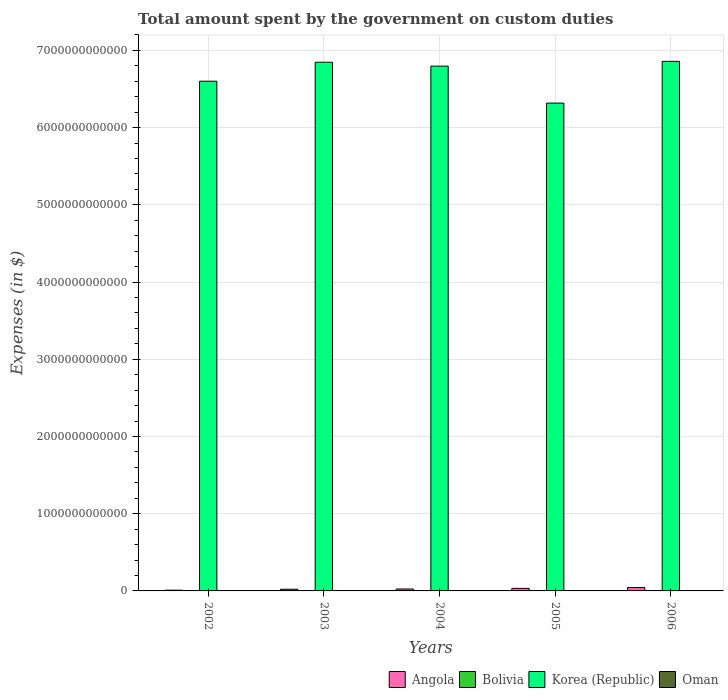Are the number of bars per tick equal to the number of legend labels?
Offer a very short reply. Yes. In how many cases, is the number of bars for a given year not equal to the number of legend labels?
Ensure brevity in your answer.  0. What is the amount spent on custom duties by the government in Korea (Republic) in 2002?
Give a very brief answer. 6.60e+12. Across all years, what is the maximum amount spent on custom duties by the government in Bolivia?
Give a very brief answer. 7.50e+08. Across all years, what is the minimum amount spent on custom duties by the government in Angola?
Ensure brevity in your answer.  9.70e+09. In which year was the amount spent on custom duties by the government in Korea (Republic) maximum?
Offer a terse response. 2006. What is the total amount spent on custom duties by the government in Korea (Republic) in the graph?
Ensure brevity in your answer.  3.34e+13. What is the difference between the amount spent on custom duties by the government in Angola in 2003 and that in 2004?
Make the answer very short. -2.82e+09. What is the difference between the amount spent on custom duties by the government in Korea (Republic) in 2005 and the amount spent on custom duties by the government in Oman in 2002?
Offer a very short reply. 6.32e+12. What is the average amount spent on custom duties by the government in Bolivia per year?
Offer a very short reply. 5.74e+08. In the year 2002, what is the difference between the amount spent on custom duties by the government in Oman and amount spent on custom duties by the government in Korea (Republic)?
Offer a very short reply. -6.60e+12. In how many years, is the amount spent on custom duties by the government in Korea (Republic) greater than 5600000000000 $?
Ensure brevity in your answer.  5. What is the ratio of the amount spent on custom duties by the government in Bolivia in 2003 to that in 2006?
Offer a terse response. 0.61. Is the amount spent on custom duties by the government in Angola in 2003 less than that in 2006?
Make the answer very short. Yes. What is the difference between the highest and the second highest amount spent on custom duties by the government in Bolivia?
Your response must be concise. 1.02e+08. What is the difference between the highest and the lowest amount spent on custom duties by the government in Korea (Republic)?
Ensure brevity in your answer.  5.41e+11. Is the sum of the amount spent on custom duties by the government in Korea (Republic) in 2002 and 2006 greater than the maximum amount spent on custom duties by the government in Oman across all years?
Keep it short and to the point. Yes. Is it the case that in every year, the sum of the amount spent on custom duties by the government in Bolivia and amount spent on custom duties by the government in Angola is greater than the sum of amount spent on custom duties by the government in Korea (Republic) and amount spent on custom duties by the government in Oman?
Keep it short and to the point. No. What does the 4th bar from the right in 2006 represents?
Provide a short and direct response. Angola. Is it the case that in every year, the sum of the amount spent on custom duties by the government in Korea (Republic) and amount spent on custom duties by the government in Angola is greater than the amount spent on custom duties by the government in Bolivia?
Give a very brief answer. Yes. How many bars are there?
Provide a short and direct response. 20. How many years are there in the graph?
Your answer should be very brief. 5. What is the difference between two consecutive major ticks on the Y-axis?
Your response must be concise. 1.00e+12. Are the values on the major ticks of Y-axis written in scientific E-notation?
Ensure brevity in your answer.  No. Does the graph contain grids?
Your response must be concise. Yes. How are the legend labels stacked?
Your answer should be compact. Horizontal. What is the title of the graph?
Your answer should be compact. Total amount spent by the government on custom duties. Does "Ukraine" appear as one of the legend labels in the graph?
Offer a terse response. No. What is the label or title of the X-axis?
Provide a short and direct response. Years. What is the label or title of the Y-axis?
Your response must be concise. Expenses (in $). What is the Expenses (in $) of Angola in 2002?
Provide a succinct answer. 9.70e+09. What is the Expenses (in $) of Bolivia in 2002?
Make the answer very short. 4.88e+08. What is the Expenses (in $) of Korea (Republic) in 2002?
Provide a succinct answer. 6.60e+12. What is the Expenses (in $) of Oman in 2002?
Offer a terse response. 6.02e+07. What is the Expenses (in $) in Angola in 2003?
Keep it short and to the point. 2.20e+1. What is the Expenses (in $) in Bolivia in 2003?
Provide a succinct answer. 4.55e+08. What is the Expenses (in $) of Korea (Republic) in 2003?
Make the answer very short. 6.85e+12. What is the Expenses (in $) of Oman in 2003?
Your response must be concise. 6.50e+07. What is the Expenses (in $) of Angola in 2004?
Give a very brief answer. 2.48e+1. What is the Expenses (in $) of Bolivia in 2004?
Your response must be concise. 5.28e+08. What is the Expenses (in $) in Korea (Republic) in 2004?
Your answer should be compact. 6.80e+12. What is the Expenses (in $) of Oman in 2004?
Provide a succinct answer. 7.10e+07. What is the Expenses (in $) in Angola in 2005?
Your answer should be very brief. 3.32e+1. What is the Expenses (in $) of Bolivia in 2005?
Offer a very short reply. 6.48e+08. What is the Expenses (in $) of Korea (Republic) in 2005?
Offer a terse response. 6.32e+12. What is the Expenses (in $) in Oman in 2005?
Give a very brief answer. 8.85e+07. What is the Expenses (in $) in Angola in 2006?
Provide a succinct answer. 4.37e+1. What is the Expenses (in $) of Bolivia in 2006?
Keep it short and to the point. 7.50e+08. What is the Expenses (in $) of Korea (Republic) in 2006?
Ensure brevity in your answer.  6.86e+12. What is the Expenses (in $) of Oman in 2006?
Keep it short and to the point. 1.15e+08. Across all years, what is the maximum Expenses (in $) in Angola?
Your answer should be very brief. 4.37e+1. Across all years, what is the maximum Expenses (in $) of Bolivia?
Your response must be concise. 7.50e+08. Across all years, what is the maximum Expenses (in $) in Korea (Republic)?
Your answer should be compact. 6.86e+12. Across all years, what is the maximum Expenses (in $) in Oman?
Keep it short and to the point. 1.15e+08. Across all years, what is the minimum Expenses (in $) in Angola?
Provide a short and direct response. 9.70e+09. Across all years, what is the minimum Expenses (in $) of Bolivia?
Make the answer very short. 4.55e+08. Across all years, what is the minimum Expenses (in $) of Korea (Republic)?
Provide a succinct answer. 6.32e+12. Across all years, what is the minimum Expenses (in $) of Oman?
Ensure brevity in your answer.  6.02e+07. What is the total Expenses (in $) in Angola in the graph?
Provide a succinct answer. 1.33e+11. What is the total Expenses (in $) of Bolivia in the graph?
Provide a succinct answer. 2.87e+09. What is the total Expenses (in $) of Korea (Republic) in the graph?
Provide a short and direct response. 3.34e+13. What is the total Expenses (in $) in Oman in the graph?
Give a very brief answer. 3.99e+08. What is the difference between the Expenses (in $) of Angola in 2002 and that in 2003?
Provide a short and direct response. -1.23e+1. What is the difference between the Expenses (in $) in Bolivia in 2002 and that in 2003?
Your answer should be very brief. 3.30e+07. What is the difference between the Expenses (in $) in Korea (Republic) in 2002 and that in 2003?
Your response must be concise. -2.46e+11. What is the difference between the Expenses (in $) of Oman in 2002 and that in 2003?
Offer a terse response. -4.80e+06. What is the difference between the Expenses (in $) in Angola in 2002 and that in 2004?
Give a very brief answer. -1.51e+1. What is the difference between the Expenses (in $) of Bolivia in 2002 and that in 2004?
Make the answer very short. -4.01e+07. What is the difference between the Expenses (in $) of Korea (Republic) in 2002 and that in 2004?
Give a very brief answer. -1.95e+11. What is the difference between the Expenses (in $) in Oman in 2002 and that in 2004?
Offer a terse response. -1.08e+07. What is the difference between the Expenses (in $) of Angola in 2002 and that in 2005?
Offer a terse response. -2.35e+1. What is the difference between the Expenses (in $) in Bolivia in 2002 and that in 2005?
Your answer should be compact. -1.60e+08. What is the difference between the Expenses (in $) in Korea (Republic) in 2002 and that in 2005?
Offer a very short reply. 2.84e+11. What is the difference between the Expenses (in $) of Oman in 2002 and that in 2005?
Ensure brevity in your answer.  -2.83e+07. What is the difference between the Expenses (in $) in Angola in 2002 and that in 2006?
Your response must be concise. -3.40e+1. What is the difference between the Expenses (in $) of Bolivia in 2002 and that in 2006?
Your answer should be compact. -2.62e+08. What is the difference between the Expenses (in $) of Korea (Republic) in 2002 and that in 2006?
Provide a succinct answer. -2.57e+11. What is the difference between the Expenses (in $) in Oman in 2002 and that in 2006?
Keep it short and to the point. -5.44e+07. What is the difference between the Expenses (in $) in Angola in 2003 and that in 2004?
Give a very brief answer. -2.82e+09. What is the difference between the Expenses (in $) of Bolivia in 2003 and that in 2004?
Your response must be concise. -7.31e+07. What is the difference between the Expenses (in $) in Korea (Republic) in 2003 and that in 2004?
Offer a terse response. 5.08e+1. What is the difference between the Expenses (in $) in Oman in 2003 and that in 2004?
Your answer should be compact. -6.00e+06. What is the difference between the Expenses (in $) of Angola in 2003 and that in 2005?
Your response must be concise. -1.12e+1. What is the difference between the Expenses (in $) of Bolivia in 2003 and that in 2005?
Your answer should be very brief. -1.93e+08. What is the difference between the Expenses (in $) of Korea (Republic) in 2003 and that in 2005?
Offer a terse response. 5.30e+11. What is the difference between the Expenses (in $) in Oman in 2003 and that in 2005?
Provide a short and direct response. -2.35e+07. What is the difference between the Expenses (in $) of Angola in 2003 and that in 2006?
Provide a short and direct response. -2.17e+1. What is the difference between the Expenses (in $) of Bolivia in 2003 and that in 2006?
Your answer should be very brief. -2.95e+08. What is the difference between the Expenses (in $) of Korea (Republic) in 2003 and that in 2006?
Provide a short and direct response. -1.11e+1. What is the difference between the Expenses (in $) of Oman in 2003 and that in 2006?
Offer a very short reply. -4.96e+07. What is the difference between the Expenses (in $) of Angola in 2004 and that in 2005?
Offer a very short reply. -8.36e+09. What is the difference between the Expenses (in $) of Bolivia in 2004 and that in 2005?
Your answer should be compact. -1.20e+08. What is the difference between the Expenses (in $) in Korea (Republic) in 2004 and that in 2005?
Provide a short and direct response. 4.79e+11. What is the difference between the Expenses (in $) in Oman in 2004 and that in 2005?
Offer a terse response. -1.75e+07. What is the difference between the Expenses (in $) of Angola in 2004 and that in 2006?
Offer a very short reply. -1.89e+1. What is the difference between the Expenses (in $) of Bolivia in 2004 and that in 2006?
Provide a short and direct response. -2.22e+08. What is the difference between the Expenses (in $) in Korea (Republic) in 2004 and that in 2006?
Give a very brief answer. -6.19e+1. What is the difference between the Expenses (in $) of Oman in 2004 and that in 2006?
Ensure brevity in your answer.  -4.36e+07. What is the difference between the Expenses (in $) of Angola in 2005 and that in 2006?
Offer a very short reply. -1.05e+1. What is the difference between the Expenses (in $) in Bolivia in 2005 and that in 2006?
Give a very brief answer. -1.02e+08. What is the difference between the Expenses (in $) in Korea (Republic) in 2005 and that in 2006?
Keep it short and to the point. -5.41e+11. What is the difference between the Expenses (in $) in Oman in 2005 and that in 2006?
Your response must be concise. -2.61e+07. What is the difference between the Expenses (in $) in Angola in 2002 and the Expenses (in $) in Bolivia in 2003?
Keep it short and to the point. 9.25e+09. What is the difference between the Expenses (in $) of Angola in 2002 and the Expenses (in $) of Korea (Republic) in 2003?
Ensure brevity in your answer.  -6.84e+12. What is the difference between the Expenses (in $) in Angola in 2002 and the Expenses (in $) in Oman in 2003?
Offer a very short reply. 9.64e+09. What is the difference between the Expenses (in $) in Bolivia in 2002 and the Expenses (in $) in Korea (Republic) in 2003?
Offer a very short reply. -6.85e+12. What is the difference between the Expenses (in $) of Bolivia in 2002 and the Expenses (in $) of Oman in 2003?
Give a very brief answer. 4.23e+08. What is the difference between the Expenses (in $) of Korea (Republic) in 2002 and the Expenses (in $) of Oman in 2003?
Ensure brevity in your answer.  6.60e+12. What is the difference between the Expenses (in $) in Angola in 2002 and the Expenses (in $) in Bolivia in 2004?
Your response must be concise. 9.17e+09. What is the difference between the Expenses (in $) of Angola in 2002 and the Expenses (in $) of Korea (Republic) in 2004?
Make the answer very short. -6.79e+12. What is the difference between the Expenses (in $) in Angola in 2002 and the Expenses (in $) in Oman in 2004?
Keep it short and to the point. 9.63e+09. What is the difference between the Expenses (in $) in Bolivia in 2002 and the Expenses (in $) in Korea (Republic) in 2004?
Provide a short and direct response. -6.80e+12. What is the difference between the Expenses (in $) in Bolivia in 2002 and the Expenses (in $) in Oman in 2004?
Keep it short and to the point. 4.17e+08. What is the difference between the Expenses (in $) of Korea (Republic) in 2002 and the Expenses (in $) of Oman in 2004?
Ensure brevity in your answer.  6.60e+12. What is the difference between the Expenses (in $) of Angola in 2002 and the Expenses (in $) of Bolivia in 2005?
Your answer should be compact. 9.05e+09. What is the difference between the Expenses (in $) of Angola in 2002 and the Expenses (in $) of Korea (Republic) in 2005?
Make the answer very short. -6.31e+12. What is the difference between the Expenses (in $) of Angola in 2002 and the Expenses (in $) of Oman in 2005?
Make the answer very short. 9.61e+09. What is the difference between the Expenses (in $) in Bolivia in 2002 and the Expenses (in $) in Korea (Republic) in 2005?
Provide a short and direct response. -6.32e+12. What is the difference between the Expenses (in $) in Bolivia in 2002 and the Expenses (in $) in Oman in 2005?
Provide a succinct answer. 4.00e+08. What is the difference between the Expenses (in $) in Korea (Republic) in 2002 and the Expenses (in $) in Oman in 2005?
Provide a succinct answer. 6.60e+12. What is the difference between the Expenses (in $) of Angola in 2002 and the Expenses (in $) of Bolivia in 2006?
Ensure brevity in your answer.  8.95e+09. What is the difference between the Expenses (in $) in Angola in 2002 and the Expenses (in $) in Korea (Republic) in 2006?
Your answer should be very brief. -6.85e+12. What is the difference between the Expenses (in $) in Angola in 2002 and the Expenses (in $) in Oman in 2006?
Your answer should be compact. 9.59e+09. What is the difference between the Expenses (in $) of Bolivia in 2002 and the Expenses (in $) of Korea (Republic) in 2006?
Offer a terse response. -6.86e+12. What is the difference between the Expenses (in $) of Bolivia in 2002 and the Expenses (in $) of Oman in 2006?
Make the answer very short. 3.74e+08. What is the difference between the Expenses (in $) in Korea (Republic) in 2002 and the Expenses (in $) in Oman in 2006?
Keep it short and to the point. 6.60e+12. What is the difference between the Expenses (in $) in Angola in 2003 and the Expenses (in $) in Bolivia in 2004?
Keep it short and to the point. 2.14e+1. What is the difference between the Expenses (in $) in Angola in 2003 and the Expenses (in $) in Korea (Republic) in 2004?
Offer a terse response. -6.77e+12. What is the difference between the Expenses (in $) of Angola in 2003 and the Expenses (in $) of Oman in 2004?
Offer a very short reply. 2.19e+1. What is the difference between the Expenses (in $) in Bolivia in 2003 and the Expenses (in $) in Korea (Republic) in 2004?
Your answer should be very brief. -6.80e+12. What is the difference between the Expenses (in $) in Bolivia in 2003 and the Expenses (in $) in Oman in 2004?
Keep it short and to the point. 3.84e+08. What is the difference between the Expenses (in $) of Korea (Republic) in 2003 and the Expenses (in $) of Oman in 2004?
Offer a very short reply. 6.85e+12. What is the difference between the Expenses (in $) in Angola in 2003 and the Expenses (in $) in Bolivia in 2005?
Offer a terse response. 2.13e+1. What is the difference between the Expenses (in $) of Angola in 2003 and the Expenses (in $) of Korea (Republic) in 2005?
Offer a terse response. -6.30e+12. What is the difference between the Expenses (in $) in Angola in 2003 and the Expenses (in $) in Oman in 2005?
Provide a succinct answer. 2.19e+1. What is the difference between the Expenses (in $) of Bolivia in 2003 and the Expenses (in $) of Korea (Republic) in 2005?
Give a very brief answer. -6.32e+12. What is the difference between the Expenses (in $) of Bolivia in 2003 and the Expenses (in $) of Oman in 2005?
Your response must be concise. 3.67e+08. What is the difference between the Expenses (in $) of Korea (Republic) in 2003 and the Expenses (in $) of Oman in 2005?
Provide a short and direct response. 6.85e+12. What is the difference between the Expenses (in $) in Angola in 2003 and the Expenses (in $) in Bolivia in 2006?
Your answer should be very brief. 2.12e+1. What is the difference between the Expenses (in $) of Angola in 2003 and the Expenses (in $) of Korea (Republic) in 2006?
Provide a succinct answer. -6.84e+12. What is the difference between the Expenses (in $) of Angola in 2003 and the Expenses (in $) of Oman in 2006?
Provide a short and direct response. 2.19e+1. What is the difference between the Expenses (in $) of Bolivia in 2003 and the Expenses (in $) of Korea (Republic) in 2006?
Provide a succinct answer. -6.86e+12. What is the difference between the Expenses (in $) of Bolivia in 2003 and the Expenses (in $) of Oman in 2006?
Provide a short and direct response. 3.41e+08. What is the difference between the Expenses (in $) of Korea (Republic) in 2003 and the Expenses (in $) of Oman in 2006?
Your answer should be compact. 6.85e+12. What is the difference between the Expenses (in $) in Angola in 2004 and the Expenses (in $) in Bolivia in 2005?
Your answer should be compact. 2.41e+1. What is the difference between the Expenses (in $) of Angola in 2004 and the Expenses (in $) of Korea (Republic) in 2005?
Keep it short and to the point. -6.29e+12. What is the difference between the Expenses (in $) in Angola in 2004 and the Expenses (in $) in Oman in 2005?
Ensure brevity in your answer.  2.47e+1. What is the difference between the Expenses (in $) of Bolivia in 2004 and the Expenses (in $) of Korea (Republic) in 2005?
Keep it short and to the point. -6.32e+12. What is the difference between the Expenses (in $) in Bolivia in 2004 and the Expenses (in $) in Oman in 2005?
Your answer should be very brief. 4.40e+08. What is the difference between the Expenses (in $) of Korea (Republic) in 2004 and the Expenses (in $) of Oman in 2005?
Offer a very short reply. 6.80e+12. What is the difference between the Expenses (in $) in Angola in 2004 and the Expenses (in $) in Bolivia in 2006?
Offer a terse response. 2.40e+1. What is the difference between the Expenses (in $) in Angola in 2004 and the Expenses (in $) in Korea (Republic) in 2006?
Your response must be concise. -6.83e+12. What is the difference between the Expenses (in $) in Angola in 2004 and the Expenses (in $) in Oman in 2006?
Your response must be concise. 2.47e+1. What is the difference between the Expenses (in $) of Bolivia in 2004 and the Expenses (in $) of Korea (Republic) in 2006?
Your answer should be very brief. -6.86e+12. What is the difference between the Expenses (in $) in Bolivia in 2004 and the Expenses (in $) in Oman in 2006?
Offer a terse response. 4.14e+08. What is the difference between the Expenses (in $) of Korea (Republic) in 2004 and the Expenses (in $) of Oman in 2006?
Offer a terse response. 6.80e+12. What is the difference between the Expenses (in $) of Angola in 2005 and the Expenses (in $) of Bolivia in 2006?
Your response must be concise. 3.24e+1. What is the difference between the Expenses (in $) of Angola in 2005 and the Expenses (in $) of Korea (Republic) in 2006?
Your response must be concise. -6.83e+12. What is the difference between the Expenses (in $) of Angola in 2005 and the Expenses (in $) of Oman in 2006?
Give a very brief answer. 3.30e+1. What is the difference between the Expenses (in $) of Bolivia in 2005 and the Expenses (in $) of Korea (Republic) in 2006?
Offer a terse response. -6.86e+12. What is the difference between the Expenses (in $) in Bolivia in 2005 and the Expenses (in $) in Oman in 2006?
Your answer should be compact. 5.34e+08. What is the difference between the Expenses (in $) in Korea (Republic) in 2005 and the Expenses (in $) in Oman in 2006?
Your response must be concise. 6.32e+12. What is the average Expenses (in $) of Angola per year?
Ensure brevity in your answer.  2.67e+1. What is the average Expenses (in $) in Bolivia per year?
Your answer should be very brief. 5.74e+08. What is the average Expenses (in $) in Korea (Republic) per year?
Your response must be concise. 6.68e+12. What is the average Expenses (in $) in Oman per year?
Make the answer very short. 7.99e+07. In the year 2002, what is the difference between the Expenses (in $) of Angola and Expenses (in $) of Bolivia?
Provide a short and direct response. 9.21e+09. In the year 2002, what is the difference between the Expenses (in $) of Angola and Expenses (in $) of Korea (Republic)?
Your answer should be compact. -6.59e+12. In the year 2002, what is the difference between the Expenses (in $) of Angola and Expenses (in $) of Oman?
Your answer should be compact. 9.64e+09. In the year 2002, what is the difference between the Expenses (in $) of Bolivia and Expenses (in $) of Korea (Republic)?
Provide a succinct answer. -6.60e+12. In the year 2002, what is the difference between the Expenses (in $) of Bolivia and Expenses (in $) of Oman?
Provide a succinct answer. 4.28e+08. In the year 2002, what is the difference between the Expenses (in $) of Korea (Republic) and Expenses (in $) of Oman?
Your answer should be compact. 6.60e+12. In the year 2003, what is the difference between the Expenses (in $) in Angola and Expenses (in $) in Bolivia?
Your response must be concise. 2.15e+1. In the year 2003, what is the difference between the Expenses (in $) of Angola and Expenses (in $) of Korea (Republic)?
Keep it short and to the point. -6.83e+12. In the year 2003, what is the difference between the Expenses (in $) in Angola and Expenses (in $) in Oman?
Your answer should be very brief. 2.19e+1. In the year 2003, what is the difference between the Expenses (in $) in Bolivia and Expenses (in $) in Korea (Republic)?
Make the answer very short. -6.85e+12. In the year 2003, what is the difference between the Expenses (in $) in Bolivia and Expenses (in $) in Oman?
Offer a very short reply. 3.90e+08. In the year 2003, what is the difference between the Expenses (in $) in Korea (Republic) and Expenses (in $) in Oman?
Offer a terse response. 6.85e+12. In the year 2004, what is the difference between the Expenses (in $) of Angola and Expenses (in $) of Bolivia?
Offer a very short reply. 2.43e+1. In the year 2004, what is the difference between the Expenses (in $) of Angola and Expenses (in $) of Korea (Republic)?
Ensure brevity in your answer.  -6.77e+12. In the year 2004, what is the difference between the Expenses (in $) of Angola and Expenses (in $) of Oman?
Provide a succinct answer. 2.47e+1. In the year 2004, what is the difference between the Expenses (in $) in Bolivia and Expenses (in $) in Korea (Republic)?
Ensure brevity in your answer.  -6.80e+12. In the year 2004, what is the difference between the Expenses (in $) of Bolivia and Expenses (in $) of Oman?
Keep it short and to the point. 4.57e+08. In the year 2004, what is the difference between the Expenses (in $) in Korea (Republic) and Expenses (in $) in Oman?
Keep it short and to the point. 6.80e+12. In the year 2005, what is the difference between the Expenses (in $) in Angola and Expenses (in $) in Bolivia?
Your response must be concise. 3.25e+1. In the year 2005, what is the difference between the Expenses (in $) in Angola and Expenses (in $) in Korea (Republic)?
Offer a terse response. -6.28e+12. In the year 2005, what is the difference between the Expenses (in $) of Angola and Expenses (in $) of Oman?
Offer a terse response. 3.31e+1. In the year 2005, what is the difference between the Expenses (in $) of Bolivia and Expenses (in $) of Korea (Republic)?
Give a very brief answer. -6.32e+12. In the year 2005, what is the difference between the Expenses (in $) in Bolivia and Expenses (in $) in Oman?
Provide a short and direct response. 5.60e+08. In the year 2005, what is the difference between the Expenses (in $) in Korea (Republic) and Expenses (in $) in Oman?
Give a very brief answer. 6.32e+12. In the year 2006, what is the difference between the Expenses (in $) in Angola and Expenses (in $) in Bolivia?
Your answer should be very brief. 4.29e+1. In the year 2006, what is the difference between the Expenses (in $) in Angola and Expenses (in $) in Korea (Republic)?
Keep it short and to the point. -6.81e+12. In the year 2006, what is the difference between the Expenses (in $) of Angola and Expenses (in $) of Oman?
Ensure brevity in your answer.  4.35e+1. In the year 2006, what is the difference between the Expenses (in $) in Bolivia and Expenses (in $) in Korea (Republic)?
Provide a short and direct response. -6.86e+12. In the year 2006, what is the difference between the Expenses (in $) in Bolivia and Expenses (in $) in Oman?
Your answer should be very brief. 6.36e+08. In the year 2006, what is the difference between the Expenses (in $) in Korea (Republic) and Expenses (in $) in Oman?
Offer a very short reply. 6.86e+12. What is the ratio of the Expenses (in $) in Angola in 2002 to that in 2003?
Make the answer very short. 0.44. What is the ratio of the Expenses (in $) in Bolivia in 2002 to that in 2003?
Your answer should be compact. 1.07. What is the ratio of the Expenses (in $) of Korea (Republic) in 2002 to that in 2003?
Keep it short and to the point. 0.96. What is the ratio of the Expenses (in $) in Oman in 2002 to that in 2003?
Ensure brevity in your answer.  0.93. What is the ratio of the Expenses (in $) in Angola in 2002 to that in 2004?
Your response must be concise. 0.39. What is the ratio of the Expenses (in $) of Bolivia in 2002 to that in 2004?
Give a very brief answer. 0.92. What is the ratio of the Expenses (in $) in Korea (Republic) in 2002 to that in 2004?
Offer a terse response. 0.97. What is the ratio of the Expenses (in $) of Oman in 2002 to that in 2004?
Give a very brief answer. 0.85. What is the ratio of the Expenses (in $) in Angola in 2002 to that in 2005?
Make the answer very short. 0.29. What is the ratio of the Expenses (in $) of Bolivia in 2002 to that in 2005?
Give a very brief answer. 0.75. What is the ratio of the Expenses (in $) in Korea (Republic) in 2002 to that in 2005?
Make the answer very short. 1.04. What is the ratio of the Expenses (in $) of Oman in 2002 to that in 2005?
Your answer should be compact. 0.68. What is the ratio of the Expenses (in $) of Angola in 2002 to that in 2006?
Keep it short and to the point. 0.22. What is the ratio of the Expenses (in $) of Bolivia in 2002 to that in 2006?
Offer a terse response. 0.65. What is the ratio of the Expenses (in $) in Korea (Republic) in 2002 to that in 2006?
Make the answer very short. 0.96. What is the ratio of the Expenses (in $) in Oman in 2002 to that in 2006?
Your answer should be compact. 0.53. What is the ratio of the Expenses (in $) in Angola in 2003 to that in 2004?
Give a very brief answer. 0.89. What is the ratio of the Expenses (in $) of Bolivia in 2003 to that in 2004?
Give a very brief answer. 0.86. What is the ratio of the Expenses (in $) in Korea (Republic) in 2003 to that in 2004?
Make the answer very short. 1.01. What is the ratio of the Expenses (in $) in Oman in 2003 to that in 2004?
Your response must be concise. 0.92. What is the ratio of the Expenses (in $) in Angola in 2003 to that in 2005?
Offer a very short reply. 0.66. What is the ratio of the Expenses (in $) of Bolivia in 2003 to that in 2005?
Your answer should be very brief. 0.7. What is the ratio of the Expenses (in $) in Korea (Republic) in 2003 to that in 2005?
Provide a short and direct response. 1.08. What is the ratio of the Expenses (in $) of Oman in 2003 to that in 2005?
Your answer should be very brief. 0.73. What is the ratio of the Expenses (in $) in Angola in 2003 to that in 2006?
Offer a very short reply. 0.5. What is the ratio of the Expenses (in $) in Bolivia in 2003 to that in 2006?
Offer a terse response. 0.61. What is the ratio of the Expenses (in $) of Korea (Republic) in 2003 to that in 2006?
Your answer should be very brief. 1. What is the ratio of the Expenses (in $) of Oman in 2003 to that in 2006?
Give a very brief answer. 0.57. What is the ratio of the Expenses (in $) of Angola in 2004 to that in 2005?
Ensure brevity in your answer.  0.75. What is the ratio of the Expenses (in $) in Bolivia in 2004 to that in 2005?
Offer a terse response. 0.81. What is the ratio of the Expenses (in $) in Korea (Republic) in 2004 to that in 2005?
Your response must be concise. 1.08. What is the ratio of the Expenses (in $) of Oman in 2004 to that in 2005?
Give a very brief answer. 0.8. What is the ratio of the Expenses (in $) in Angola in 2004 to that in 2006?
Your answer should be compact. 0.57. What is the ratio of the Expenses (in $) of Bolivia in 2004 to that in 2006?
Your answer should be compact. 0.7. What is the ratio of the Expenses (in $) of Korea (Republic) in 2004 to that in 2006?
Give a very brief answer. 0.99. What is the ratio of the Expenses (in $) in Oman in 2004 to that in 2006?
Provide a succinct answer. 0.62. What is the ratio of the Expenses (in $) of Angola in 2005 to that in 2006?
Make the answer very short. 0.76. What is the ratio of the Expenses (in $) in Bolivia in 2005 to that in 2006?
Your answer should be compact. 0.86. What is the ratio of the Expenses (in $) in Korea (Republic) in 2005 to that in 2006?
Your answer should be compact. 0.92. What is the ratio of the Expenses (in $) in Oman in 2005 to that in 2006?
Offer a terse response. 0.77. What is the difference between the highest and the second highest Expenses (in $) of Angola?
Your answer should be compact. 1.05e+1. What is the difference between the highest and the second highest Expenses (in $) in Bolivia?
Your response must be concise. 1.02e+08. What is the difference between the highest and the second highest Expenses (in $) in Korea (Republic)?
Your answer should be very brief. 1.11e+1. What is the difference between the highest and the second highest Expenses (in $) of Oman?
Provide a succinct answer. 2.61e+07. What is the difference between the highest and the lowest Expenses (in $) of Angola?
Offer a terse response. 3.40e+1. What is the difference between the highest and the lowest Expenses (in $) in Bolivia?
Give a very brief answer. 2.95e+08. What is the difference between the highest and the lowest Expenses (in $) of Korea (Republic)?
Give a very brief answer. 5.41e+11. What is the difference between the highest and the lowest Expenses (in $) of Oman?
Ensure brevity in your answer.  5.44e+07. 